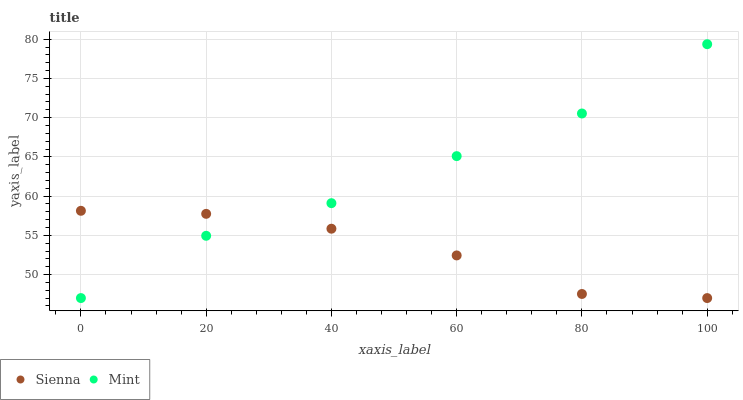Does Sienna have the minimum area under the curve?
Answer yes or no. Yes. Does Mint have the maximum area under the curve?
Answer yes or no. Yes. Does Mint have the minimum area under the curve?
Answer yes or no. No. Is Sienna the smoothest?
Answer yes or no. Yes. Is Mint the roughest?
Answer yes or no. Yes. Is Mint the smoothest?
Answer yes or no. No. Does Sienna have the lowest value?
Answer yes or no. Yes. Does Mint have the highest value?
Answer yes or no. Yes. Does Sienna intersect Mint?
Answer yes or no. Yes. Is Sienna less than Mint?
Answer yes or no. No. Is Sienna greater than Mint?
Answer yes or no. No. 